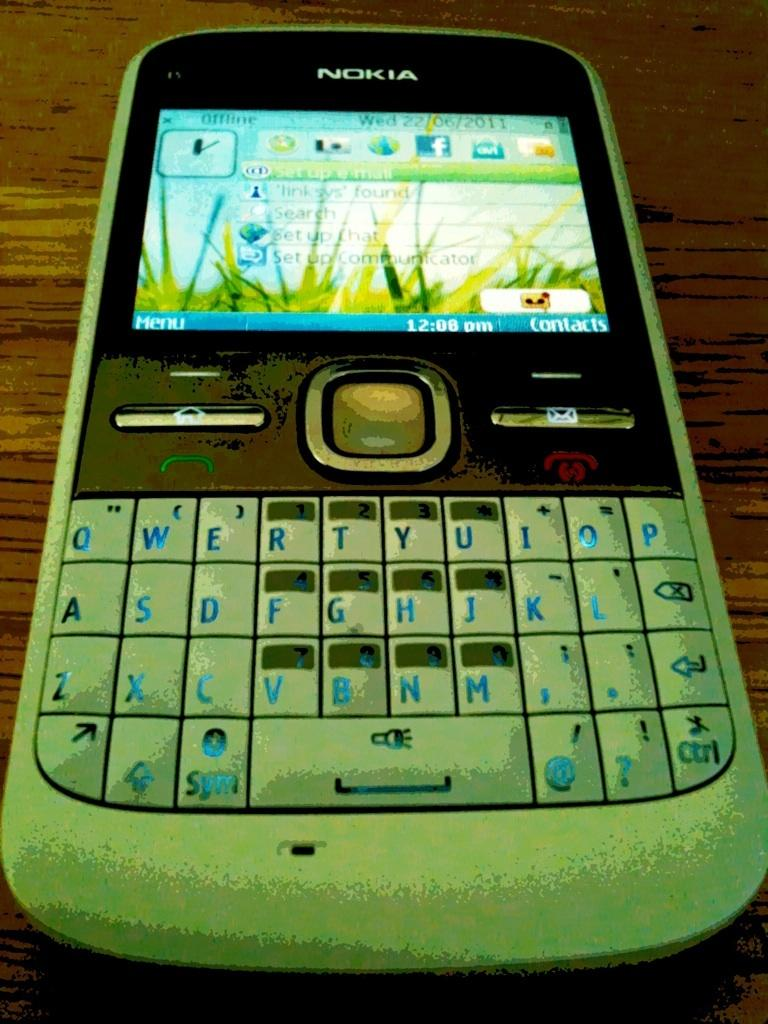<image>
Offer a succinct explanation of the picture presented. A Nokia phone displaying the time of 12:08 pm 